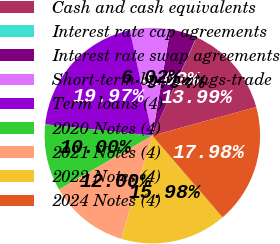Convert chart to OTSL. <chart><loc_0><loc_0><loc_500><loc_500><pie_chart><fcel>Cash and cash equivalents<fcel>Interest rate cap agreements<fcel>Interest rate swap agreements<fcel>Short-term borrowings-trade<fcel>Term loans (4)<fcel>2020 Notes (4)<fcel>2021 Notes (4)<fcel>2022 Notes (4)<fcel>2024 Notes (4)<nl><fcel>13.99%<fcel>0.04%<fcel>4.02%<fcel>6.02%<fcel>19.97%<fcel>10.0%<fcel>12.0%<fcel>15.98%<fcel>17.98%<nl></chart> 